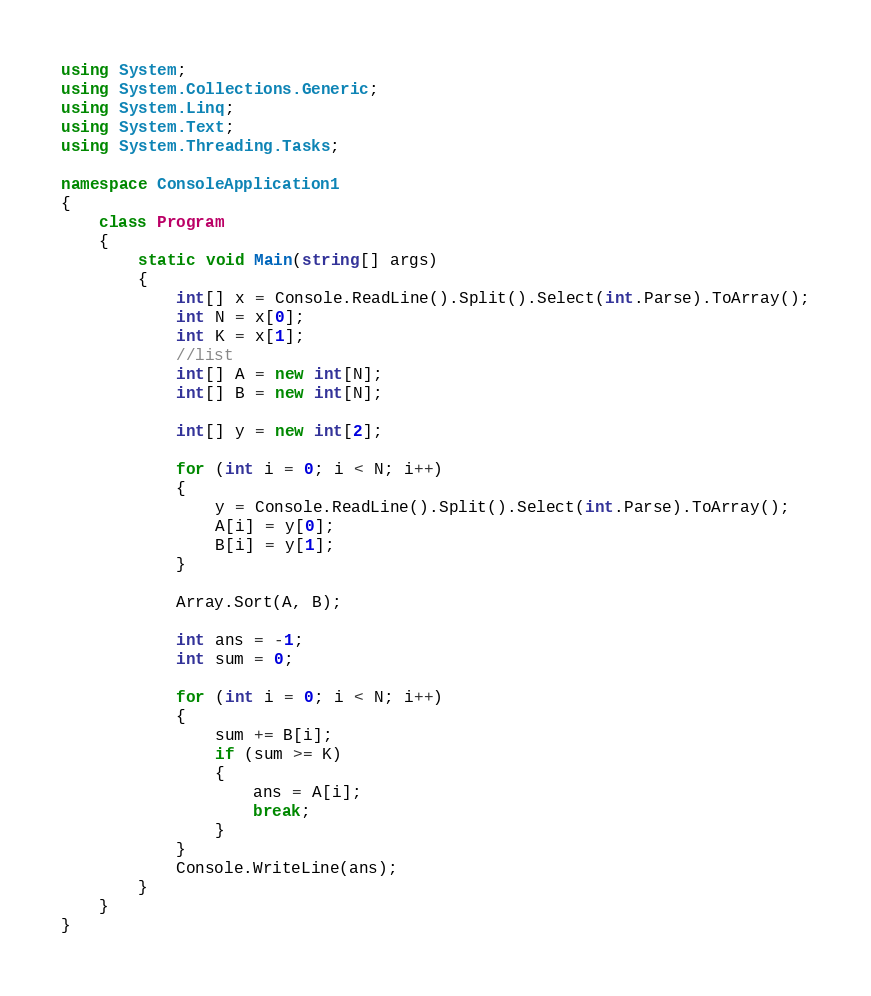Convert code to text. <code><loc_0><loc_0><loc_500><loc_500><_C#_>using System;
using System.Collections.Generic;
using System.Linq;
using System.Text;
using System.Threading.Tasks;

namespace ConsoleApplication1
{
    class Program
    {
        static void Main(string[] args)
        {
            int[] x = Console.ReadLine().Split().Select(int.Parse).ToArray();
            int N = x[0];
            int K = x[1];
            //list
            int[] A = new int[N];
            int[] B = new int[N];

            int[] y = new int[2];

            for (int i = 0; i < N; i++)
            {
                y = Console.ReadLine().Split().Select(int.Parse).ToArray();
                A[i] = y[0];
                B[i] = y[1];
            }

            Array.Sort(A, B);

            int ans = -1;
            int sum = 0;

            for (int i = 0; i < N; i++)
            {
                sum += B[i];
                if (sum >= K) 
                {
                    ans = A[i];
                    break;
                }
            }
            Console.WriteLine(ans);
        }
    }
}</code> 